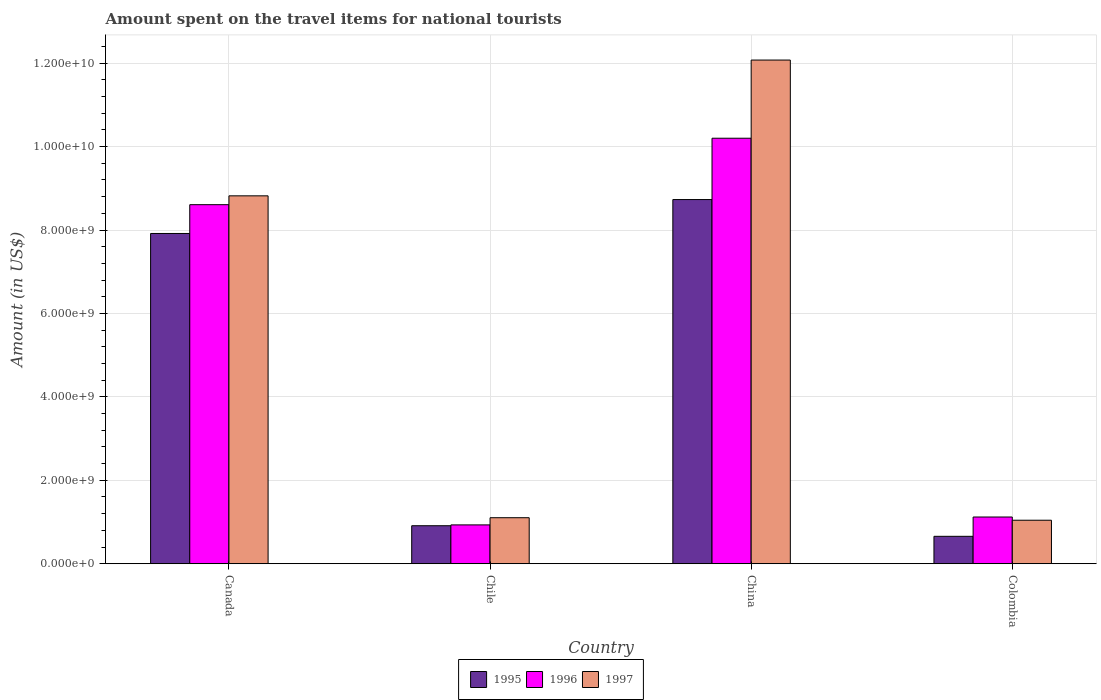How many groups of bars are there?
Offer a very short reply. 4. Are the number of bars per tick equal to the number of legend labels?
Your response must be concise. Yes. Are the number of bars on each tick of the X-axis equal?
Make the answer very short. Yes. What is the label of the 1st group of bars from the left?
Your answer should be very brief. Canada. In how many cases, is the number of bars for a given country not equal to the number of legend labels?
Give a very brief answer. 0. What is the amount spent on the travel items for national tourists in 1996 in Colombia?
Your answer should be compact. 1.12e+09. Across all countries, what is the maximum amount spent on the travel items for national tourists in 1995?
Your answer should be very brief. 8.73e+09. Across all countries, what is the minimum amount spent on the travel items for national tourists in 1996?
Make the answer very short. 9.31e+08. In which country was the amount spent on the travel items for national tourists in 1995 minimum?
Give a very brief answer. Colombia. What is the total amount spent on the travel items for national tourists in 1997 in the graph?
Ensure brevity in your answer.  2.30e+1. What is the difference between the amount spent on the travel items for national tourists in 1997 in Canada and that in China?
Offer a terse response. -3.26e+09. What is the difference between the amount spent on the travel items for national tourists in 1995 in Chile and the amount spent on the travel items for national tourists in 1997 in Canada?
Ensure brevity in your answer.  -7.91e+09. What is the average amount spent on the travel items for national tourists in 1995 per country?
Ensure brevity in your answer.  4.55e+09. What is the difference between the amount spent on the travel items for national tourists of/in 1997 and amount spent on the travel items for national tourists of/in 1995 in Chile?
Offer a very short reply. 1.92e+08. In how many countries, is the amount spent on the travel items for national tourists in 1997 greater than 1600000000 US$?
Ensure brevity in your answer.  2. What is the ratio of the amount spent on the travel items for national tourists in 1995 in Canada to that in China?
Make the answer very short. 0.91. Is the amount spent on the travel items for national tourists in 1997 in Canada less than that in Colombia?
Your response must be concise. No. What is the difference between the highest and the second highest amount spent on the travel items for national tourists in 1995?
Keep it short and to the point. 8.13e+08. What is the difference between the highest and the lowest amount spent on the travel items for national tourists in 1995?
Offer a terse response. 8.07e+09. What does the 3rd bar from the right in China represents?
Your answer should be compact. 1995. Is it the case that in every country, the sum of the amount spent on the travel items for national tourists in 1996 and amount spent on the travel items for national tourists in 1997 is greater than the amount spent on the travel items for national tourists in 1995?
Your response must be concise. Yes. How many countries are there in the graph?
Give a very brief answer. 4. Are the values on the major ticks of Y-axis written in scientific E-notation?
Offer a very short reply. Yes. How many legend labels are there?
Offer a terse response. 3. How are the legend labels stacked?
Offer a terse response. Horizontal. What is the title of the graph?
Your answer should be compact. Amount spent on the travel items for national tourists. What is the label or title of the Y-axis?
Keep it short and to the point. Amount (in US$). What is the Amount (in US$) in 1995 in Canada?
Offer a very short reply. 7.92e+09. What is the Amount (in US$) of 1996 in Canada?
Provide a short and direct response. 8.61e+09. What is the Amount (in US$) of 1997 in Canada?
Your response must be concise. 8.82e+09. What is the Amount (in US$) in 1995 in Chile?
Give a very brief answer. 9.11e+08. What is the Amount (in US$) in 1996 in Chile?
Your answer should be compact. 9.31e+08. What is the Amount (in US$) in 1997 in Chile?
Provide a short and direct response. 1.10e+09. What is the Amount (in US$) of 1995 in China?
Ensure brevity in your answer.  8.73e+09. What is the Amount (in US$) in 1996 in China?
Make the answer very short. 1.02e+1. What is the Amount (in US$) of 1997 in China?
Your answer should be very brief. 1.21e+1. What is the Amount (in US$) in 1995 in Colombia?
Your answer should be compact. 6.57e+08. What is the Amount (in US$) in 1996 in Colombia?
Give a very brief answer. 1.12e+09. What is the Amount (in US$) of 1997 in Colombia?
Your answer should be very brief. 1.04e+09. Across all countries, what is the maximum Amount (in US$) of 1995?
Offer a terse response. 8.73e+09. Across all countries, what is the maximum Amount (in US$) of 1996?
Give a very brief answer. 1.02e+1. Across all countries, what is the maximum Amount (in US$) in 1997?
Offer a very short reply. 1.21e+1. Across all countries, what is the minimum Amount (in US$) in 1995?
Offer a very short reply. 6.57e+08. Across all countries, what is the minimum Amount (in US$) of 1996?
Provide a short and direct response. 9.31e+08. Across all countries, what is the minimum Amount (in US$) in 1997?
Offer a terse response. 1.04e+09. What is the total Amount (in US$) in 1995 in the graph?
Ensure brevity in your answer.  1.82e+1. What is the total Amount (in US$) in 1996 in the graph?
Give a very brief answer. 2.09e+1. What is the total Amount (in US$) of 1997 in the graph?
Provide a succinct answer. 2.30e+1. What is the difference between the Amount (in US$) of 1995 in Canada and that in Chile?
Ensure brevity in your answer.  7.01e+09. What is the difference between the Amount (in US$) of 1996 in Canada and that in Chile?
Offer a very short reply. 7.68e+09. What is the difference between the Amount (in US$) of 1997 in Canada and that in Chile?
Your answer should be compact. 7.72e+09. What is the difference between the Amount (in US$) of 1995 in Canada and that in China?
Your response must be concise. -8.13e+08. What is the difference between the Amount (in US$) of 1996 in Canada and that in China?
Offer a terse response. -1.59e+09. What is the difference between the Amount (in US$) of 1997 in Canada and that in China?
Your answer should be very brief. -3.26e+09. What is the difference between the Amount (in US$) of 1995 in Canada and that in Colombia?
Give a very brief answer. 7.26e+09. What is the difference between the Amount (in US$) in 1996 in Canada and that in Colombia?
Offer a very short reply. 7.49e+09. What is the difference between the Amount (in US$) in 1997 in Canada and that in Colombia?
Offer a very short reply. 7.78e+09. What is the difference between the Amount (in US$) of 1995 in Chile and that in China?
Provide a succinct answer. -7.82e+09. What is the difference between the Amount (in US$) in 1996 in Chile and that in China?
Offer a terse response. -9.27e+09. What is the difference between the Amount (in US$) of 1997 in Chile and that in China?
Provide a succinct answer. -1.10e+1. What is the difference between the Amount (in US$) in 1995 in Chile and that in Colombia?
Make the answer very short. 2.54e+08. What is the difference between the Amount (in US$) in 1996 in Chile and that in Colombia?
Provide a succinct answer. -1.89e+08. What is the difference between the Amount (in US$) in 1997 in Chile and that in Colombia?
Your response must be concise. 6.00e+07. What is the difference between the Amount (in US$) in 1995 in China and that in Colombia?
Provide a succinct answer. 8.07e+09. What is the difference between the Amount (in US$) of 1996 in China and that in Colombia?
Provide a succinct answer. 9.08e+09. What is the difference between the Amount (in US$) in 1997 in China and that in Colombia?
Make the answer very short. 1.10e+1. What is the difference between the Amount (in US$) in 1995 in Canada and the Amount (in US$) in 1996 in Chile?
Offer a very short reply. 6.99e+09. What is the difference between the Amount (in US$) in 1995 in Canada and the Amount (in US$) in 1997 in Chile?
Your answer should be very brief. 6.81e+09. What is the difference between the Amount (in US$) of 1996 in Canada and the Amount (in US$) of 1997 in Chile?
Provide a succinct answer. 7.50e+09. What is the difference between the Amount (in US$) in 1995 in Canada and the Amount (in US$) in 1996 in China?
Give a very brief answer. -2.28e+09. What is the difference between the Amount (in US$) of 1995 in Canada and the Amount (in US$) of 1997 in China?
Make the answer very short. -4.16e+09. What is the difference between the Amount (in US$) in 1996 in Canada and the Amount (in US$) in 1997 in China?
Provide a short and direct response. -3.47e+09. What is the difference between the Amount (in US$) in 1995 in Canada and the Amount (in US$) in 1996 in Colombia?
Provide a short and direct response. 6.80e+09. What is the difference between the Amount (in US$) in 1995 in Canada and the Amount (in US$) in 1997 in Colombia?
Give a very brief answer. 6.87e+09. What is the difference between the Amount (in US$) of 1996 in Canada and the Amount (in US$) of 1997 in Colombia?
Offer a very short reply. 7.56e+09. What is the difference between the Amount (in US$) in 1995 in Chile and the Amount (in US$) in 1996 in China?
Your response must be concise. -9.29e+09. What is the difference between the Amount (in US$) in 1995 in Chile and the Amount (in US$) in 1997 in China?
Give a very brief answer. -1.12e+1. What is the difference between the Amount (in US$) of 1996 in Chile and the Amount (in US$) of 1997 in China?
Offer a very short reply. -1.11e+1. What is the difference between the Amount (in US$) of 1995 in Chile and the Amount (in US$) of 1996 in Colombia?
Provide a succinct answer. -2.09e+08. What is the difference between the Amount (in US$) in 1995 in Chile and the Amount (in US$) in 1997 in Colombia?
Your answer should be compact. -1.32e+08. What is the difference between the Amount (in US$) in 1996 in Chile and the Amount (in US$) in 1997 in Colombia?
Your answer should be very brief. -1.12e+08. What is the difference between the Amount (in US$) in 1995 in China and the Amount (in US$) in 1996 in Colombia?
Your answer should be compact. 7.61e+09. What is the difference between the Amount (in US$) in 1995 in China and the Amount (in US$) in 1997 in Colombia?
Give a very brief answer. 7.69e+09. What is the difference between the Amount (in US$) in 1996 in China and the Amount (in US$) in 1997 in Colombia?
Offer a very short reply. 9.16e+09. What is the average Amount (in US$) of 1995 per country?
Provide a short and direct response. 4.55e+09. What is the average Amount (in US$) in 1996 per country?
Make the answer very short. 5.21e+09. What is the average Amount (in US$) in 1997 per country?
Offer a very short reply. 5.76e+09. What is the difference between the Amount (in US$) in 1995 and Amount (in US$) in 1996 in Canada?
Keep it short and to the point. -6.90e+08. What is the difference between the Amount (in US$) of 1995 and Amount (in US$) of 1997 in Canada?
Your answer should be very brief. -9.02e+08. What is the difference between the Amount (in US$) in 1996 and Amount (in US$) in 1997 in Canada?
Your answer should be very brief. -2.12e+08. What is the difference between the Amount (in US$) of 1995 and Amount (in US$) of 1996 in Chile?
Keep it short and to the point. -2.00e+07. What is the difference between the Amount (in US$) of 1995 and Amount (in US$) of 1997 in Chile?
Provide a short and direct response. -1.92e+08. What is the difference between the Amount (in US$) in 1996 and Amount (in US$) in 1997 in Chile?
Provide a short and direct response. -1.72e+08. What is the difference between the Amount (in US$) of 1995 and Amount (in US$) of 1996 in China?
Offer a terse response. -1.47e+09. What is the difference between the Amount (in US$) of 1995 and Amount (in US$) of 1997 in China?
Keep it short and to the point. -3.34e+09. What is the difference between the Amount (in US$) in 1996 and Amount (in US$) in 1997 in China?
Make the answer very short. -1.87e+09. What is the difference between the Amount (in US$) in 1995 and Amount (in US$) in 1996 in Colombia?
Your response must be concise. -4.63e+08. What is the difference between the Amount (in US$) of 1995 and Amount (in US$) of 1997 in Colombia?
Make the answer very short. -3.86e+08. What is the difference between the Amount (in US$) in 1996 and Amount (in US$) in 1997 in Colombia?
Your answer should be compact. 7.70e+07. What is the ratio of the Amount (in US$) in 1995 in Canada to that in Chile?
Your answer should be very brief. 8.69. What is the ratio of the Amount (in US$) of 1996 in Canada to that in Chile?
Your answer should be compact. 9.24. What is the ratio of the Amount (in US$) of 1997 in Canada to that in Chile?
Offer a very short reply. 8. What is the ratio of the Amount (in US$) of 1995 in Canada to that in China?
Offer a very short reply. 0.91. What is the ratio of the Amount (in US$) of 1996 in Canada to that in China?
Ensure brevity in your answer.  0.84. What is the ratio of the Amount (in US$) of 1997 in Canada to that in China?
Offer a terse response. 0.73. What is the ratio of the Amount (in US$) of 1995 in Canada to that in Colombia?
Provide a short and direct response. 12.05. What is the ratio of the Amount (in US$) in 1996 in Canada to that in Colombia?
Make the answer very short. 7.68. What is the ratio of the Amount (in US$) in 1997 in Canada to that in Colombia?
Your response must be concise. 8.46. What is the ratio of the Amount (in US$) of 1995 in Chile to that in China?
Make the answer very short. 0.1. What is the ratio of the Amount (in US$) of 1996 in Chile to that in China?
Your response must be concise. 0.09. What is the ratio of the Amount (in US$) of 1997 in Chile to that in China?
Keep it short and to the point. 0.09. What is the ratio of the Amount (in US$) of 1995 in Chile to that in Colombia?
Your answer should be very brief. 1.39. What is the ratio of the Amount (in US$) of 1996 in Chile to that in Colombia?
Ensure brevity in your answer.  0.83. What is the ratio of the Amount (in US$) of 1997 in Chile to that in Colombia?
Offer a terse response. 1.06. What is the ratio of the Amount (in US$) in 1995 in China to that in Colombia?
Give a very brief answer. 13.29. What is the ratio of the Amount (in US$) of 1996 in China to that in Colombia?
Your answer should be compact. 9.11. What is the ratio of the Amount (in US$) of 1997 in China to that in Colombia?
Provide a succinct answer. 11.58. What is the difference between the highest and the second highest Amount (in US$) in 1995?
Offer a very short reply. 8.13e+08. What is the difference between the highest and the second highest Amount (in US$) in 1996?
Offer a very short reply. 1.59e+09. What is the difference between the highest and the second highest Amount (in US$) of 1997?
Your answer should be very brief. 3.26e+09. What is the difference between the highest and the lowest Amount (in US$) in 1995?
Offer a very short reply. 8.07e+09. What is the difference between the highest and the lowest Amount (in US$) of 1996?
Your answer should be compact. 9.27e+09. What is the difference between the highest and the lowest Amount (in US$) in 1997?
Make the answer very short. 1.10e+1. 